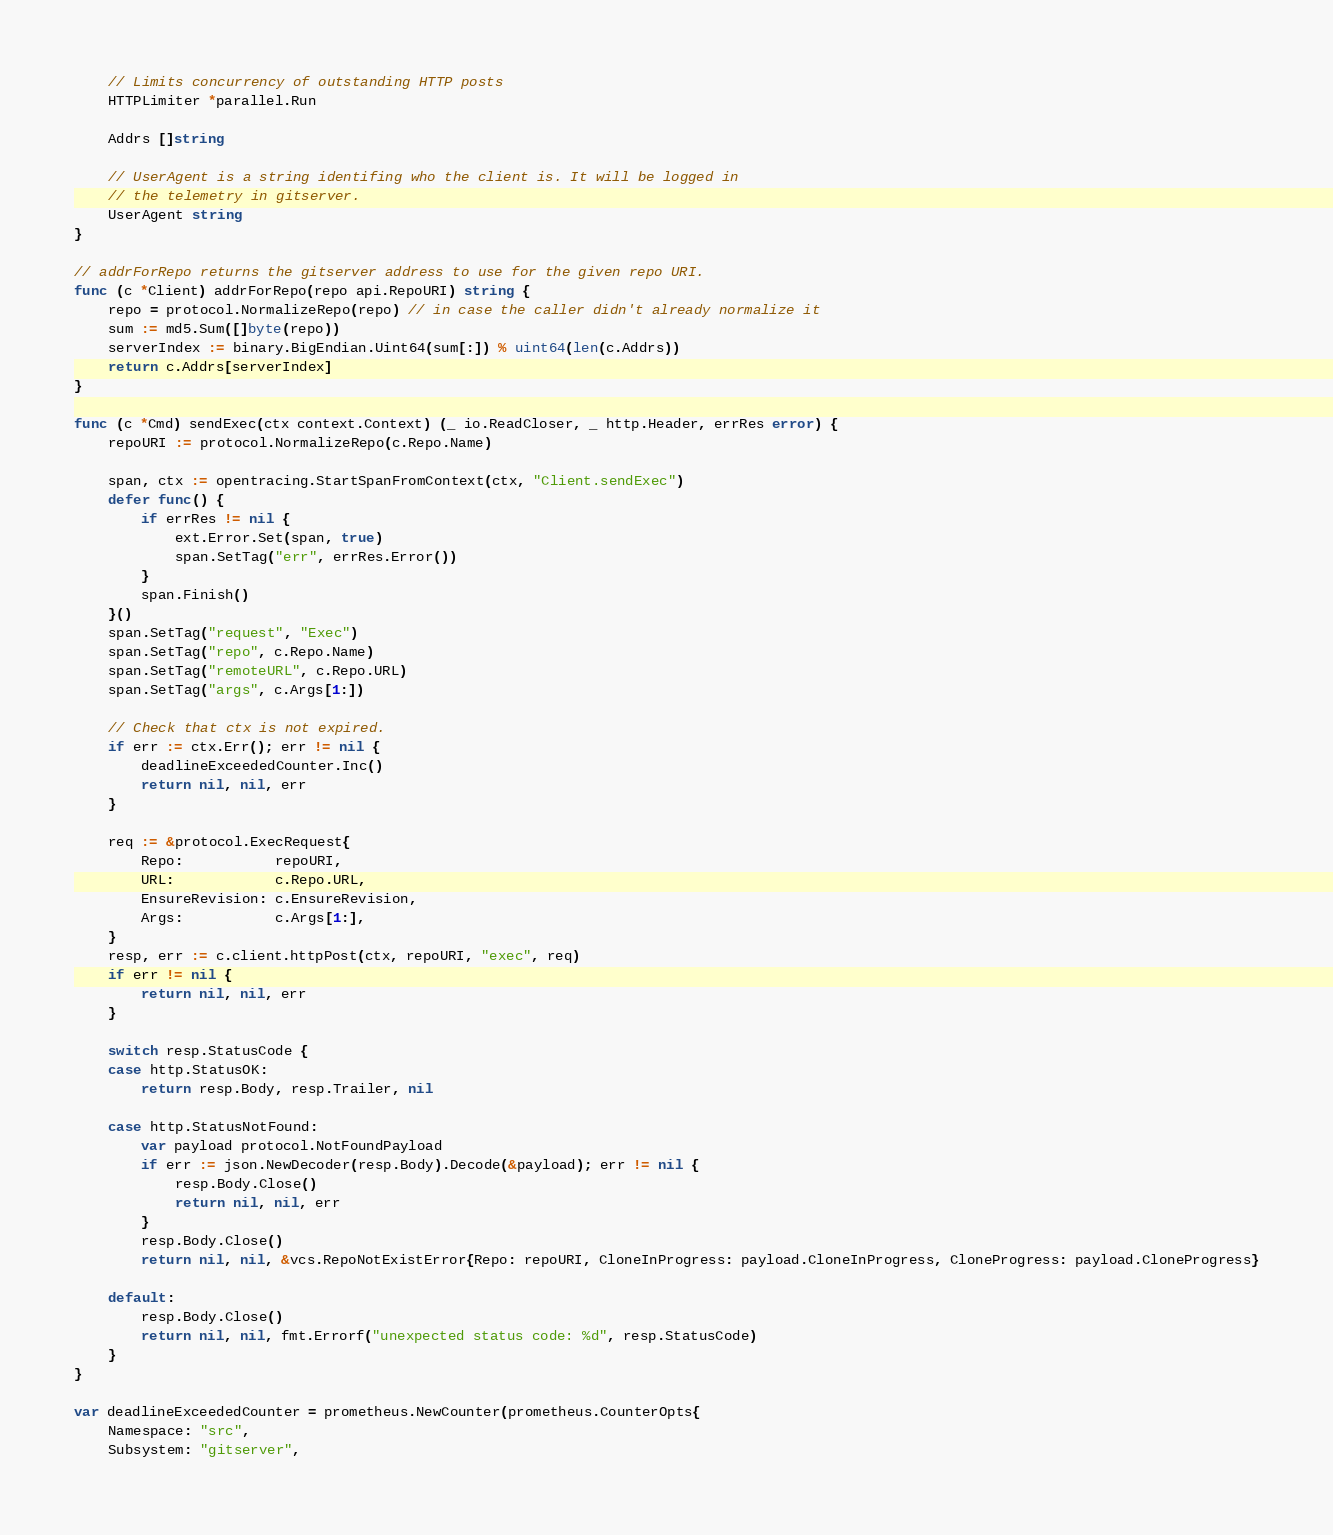Convert code to text. <code><loc_0><loc_0><loc_500><loc_500><_Go_>
	// Limits concurrency of outstanding HTTP posts
	HTTPLimiter *parallel.Run

	Addrs []string

	// UserAgent is a string identifing who the client is. It will be logged in
	// the telemetry in gitserver.
	UserAgent string
}

// addrForRepo returns the gitserver address to use for the given repo URI.
func (c *Client) addrForRepo(repo api.RepoURI) string {
	repo = protocol.NormalizeRepo(repo) // in case the caller didn't already normalize it
	sum := md5.Sum([]byte(repo))
	serverIndex := binary.BigEndian.Uint64(sum[:]) % uint64(len(c.Addrs))
	return c.Addrs[serverIndex]
}

func (c *Cmd) sendExec(ctx context.Context) (_ io.ReadCloser, _ http.Header, errRes error) {
	repoURI := protocol.NormalizeRepo(c.Repo.Name)

	span, ctx := opentracing.StartSpanFromContext(ctx, "Client.sendExec")
	defer func() {
		if errRes != nil {
			ext.Error.Set(span, true)
			span.SetTag("err", errRes.Error())
		}
		span.Finish()
	}()
	span.SetTag("request", "Exec")
	span.SetTag("repo", c.Repo.Name)
	span.SetTag("remoteURL", c.Repo.URL)
	span.SetTag("args", c.Args[1:])

	// Check that ctx is not expired.
	if err := ctx.Err(); err != nil {
		deadlineExceededCounter.Inc()
		return nil, nil, err
	}

	req := &protocol.ExecRequest{
		Repo:           repoURI,
		URL:            c.Repo.URL,
		EnsureRevision: c.EnsureRevision,
		Args:           c.Args[1:],
	}
	resp, err := c.client.httpPost(ctx, repoURI, "exec", req)
	if err != nil {
		return nil, nil, err
	}

	switch resp.StatusCode {
	case http.StatusOK:
		return resp.Body, resp.Trailer, nil

	case http.StatusNotFound:
		var payload protocol.NotFoundPayload
		if err := json.NewDecoder(resp.Body).Decode(&payload); err != nil {
			resp.Body.Close()
			return nil, nil, err
		}
		resp.Body.Close()
		return nil, nil, &vcs.RepoNotExistError{Repo: repoURI, CloneInProgress: payload.CloneInProgress, CloneProgress: payload.CloneProgress}

	default:
		resp.Body.Close()
		return nil, nil, fmt.Errorf("unexpected status code: %d", resp.StatusCode)
	}
}

var deadlineExceededCounter = prometheus.NewCounter(prometheus.CounterOpts{
	Namespace: "src",
	Subsystem: "gitserver",</code> 